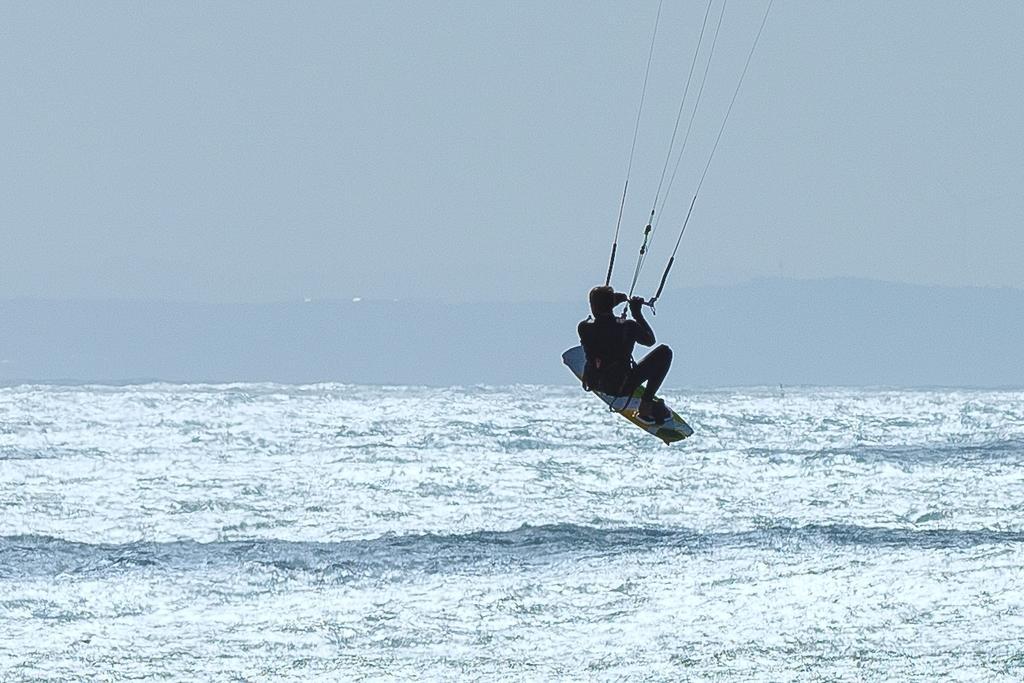Could you give a brief overview of what you see in this image? In this image a person is holding a rod having strings. He is wearing surfboard and flying in air. Bottom of image there is water having tides. Top of image there is sky. 